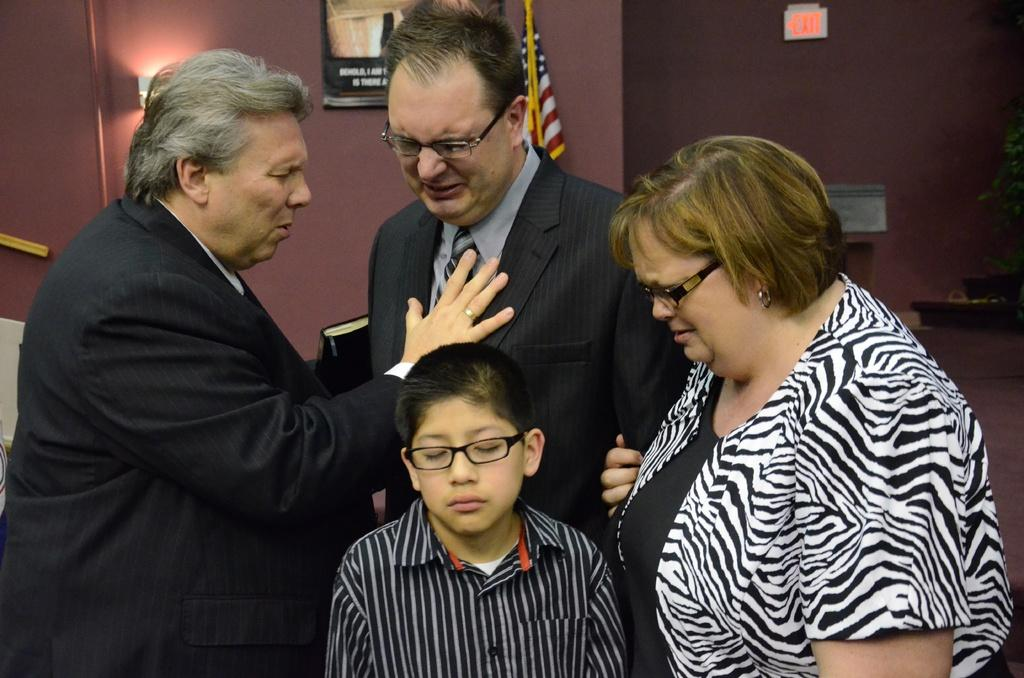How many people are in the image? There is a group of people present in the image. What colors are the dresses of some of the people in the image? Some of the people are wearing blue, black, and ash color dresses. What can be seen in the background of the image? There is a flag and boards on the wall in the background of the image. Can you tell me how many snails are crawling on the flag in the image? There are no snails present in the image, and therefore no such activity can be observed. 